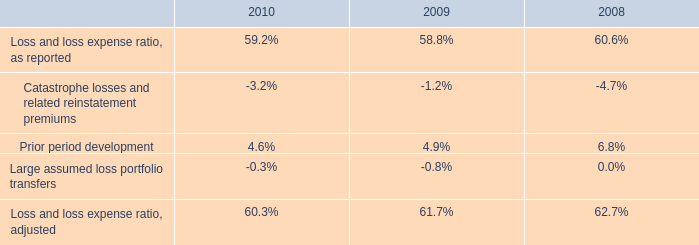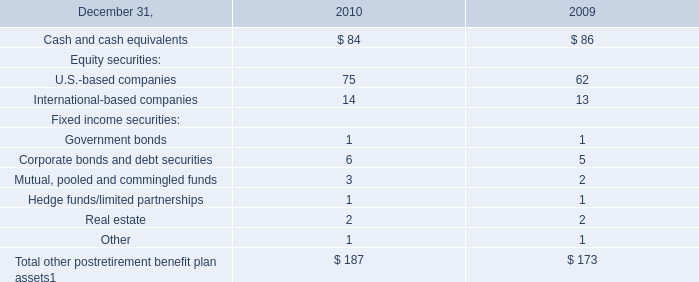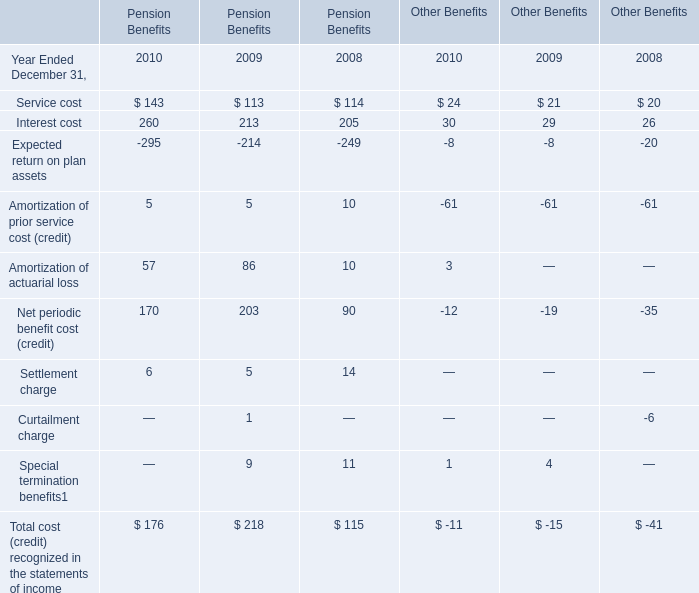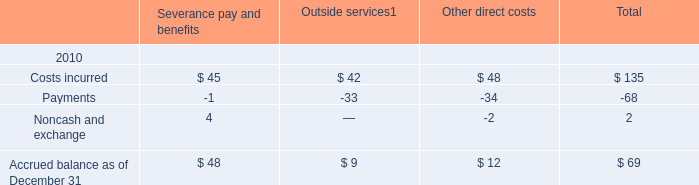What's the growth rate of Interest cost for Pension Benefits in 2010? 
Computations: ((260 - 213) / 213)
Answer: 0.22066. 